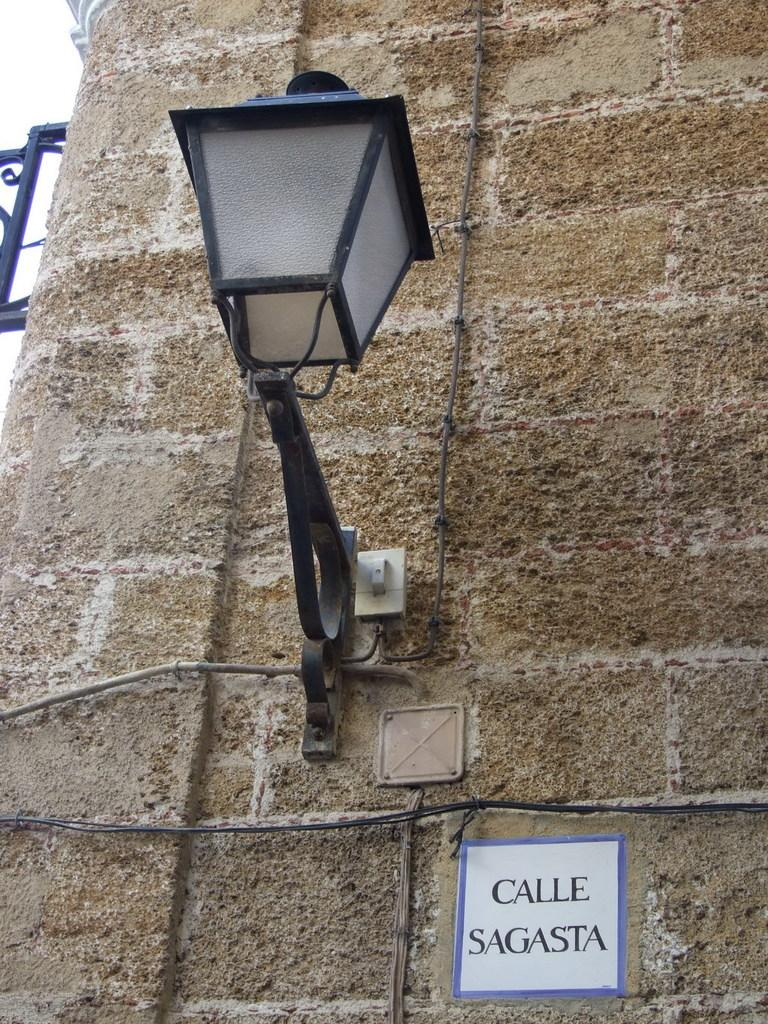What is present on the wall in the image? There is a lamp and a paper attached to the wall in the image. What is the purpose of the lamp on the wall? The lamp is likely attached to the wall for lighting purposes. What is written or depicted on the paper attached to the wall? Text is visible on the paper. How does the wall provide support for the steam in the image? There is no steam present in the image, so the wall does not provide support for steam. What type of mark is visible on the wall in the image? There is no mention of a mark on the wall in the provided facts, so we cannot determine if a mark is visible in the image. 